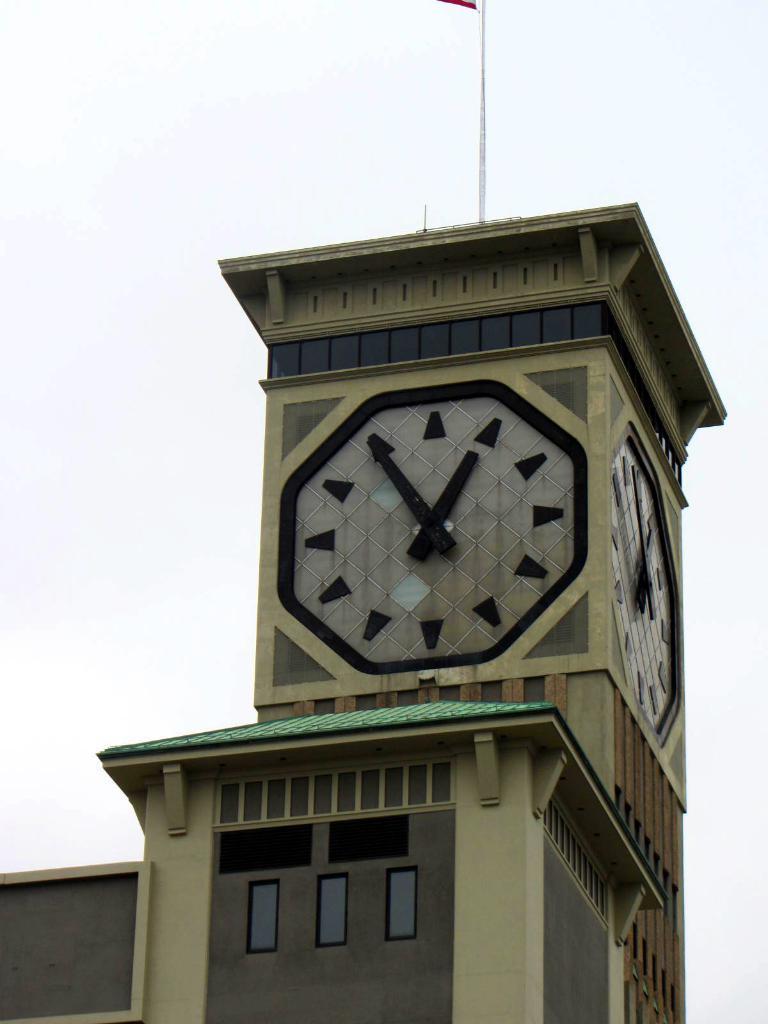Could you give a brief overview of what you see in this image? In this image, we can see a clock tower on the white background. There is a pole at the top of the image. 